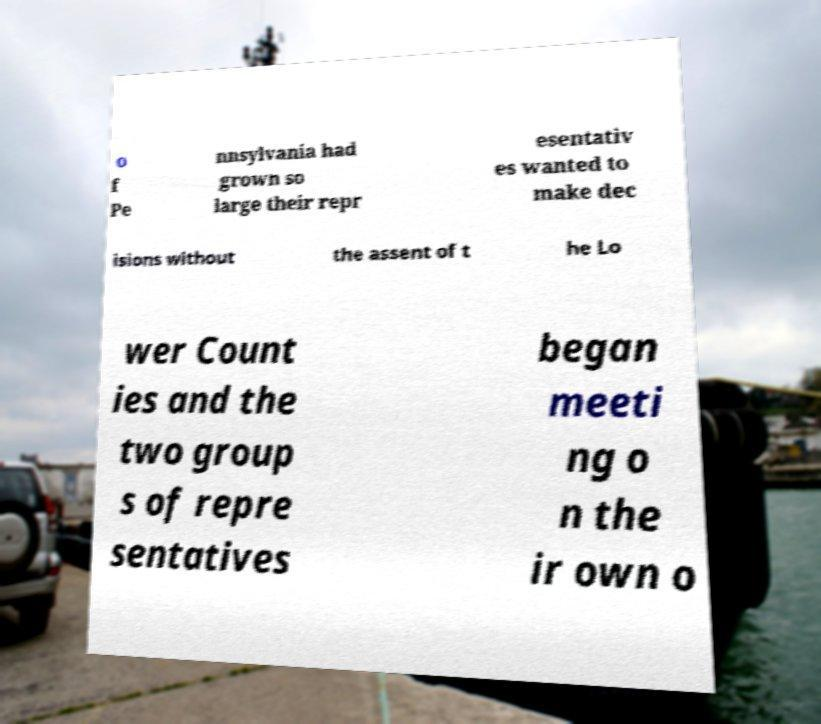I need the written content from this picture converted into text. Can you do that? o f Pe nnsylvania had grown so large their repr esentativ es wanted to make dec isions without the assent of t he Lo wer Count ies and the two group s of repre sentatives began meeti ng o n the ir own o 